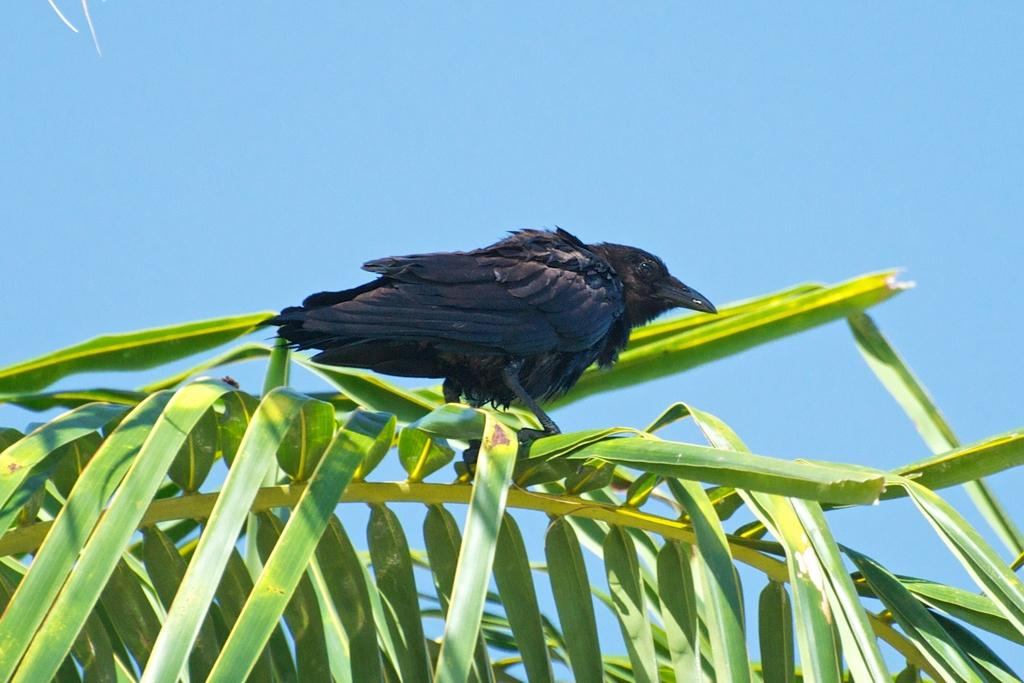What type of animal can be seen in the image? There is a bird in the image. What is the color of the bird? The bird is black in color. Where is the bird located in the image? The bird is on the leaves. What can be seen in the background of the image? The sky is visible in the background of the image. How would you describe the sky in the image? The sky is clear in the image. What type of crayon is the bird using to draw in the image? There is no crayon present in the image, and the bird is not drawing. 